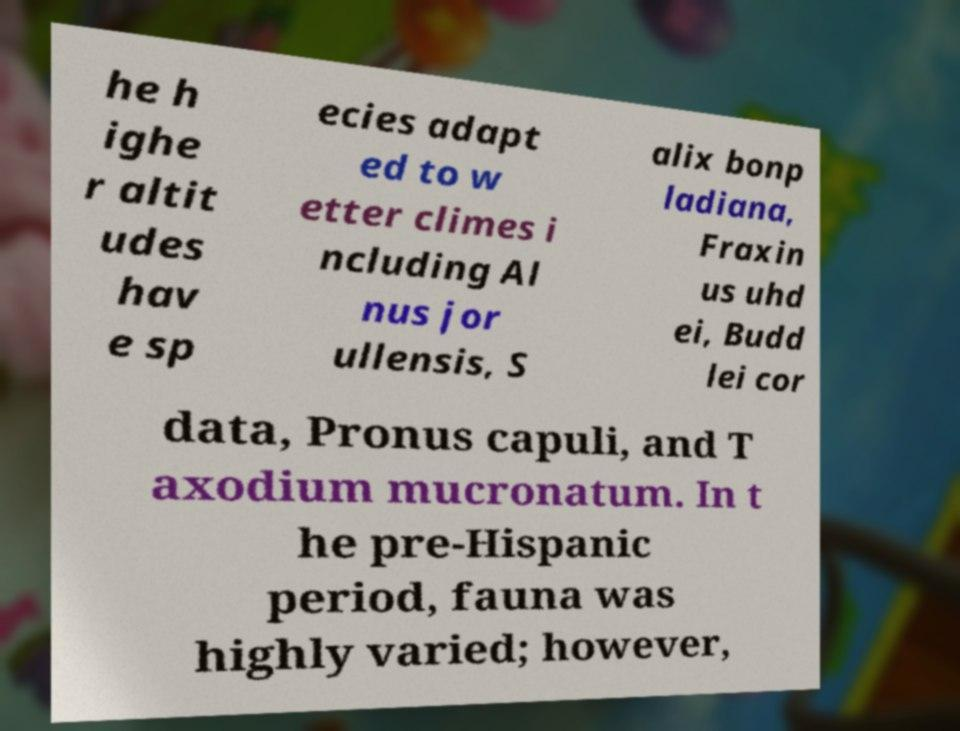There's text embedded in this image that I need extracted. Can you transcribe it verbatim? he h ighe r altit udes hav e sp ecies adapt ed to w etter climes i ncluding Al nus jor ullensis, S alix bonp ladiana, Fraxin us uhd ei, Budd lei cor data, Pronus capuli, and T axodium mucronatum. In t he pre-Hispanic period, fauna was highly varied; however, 